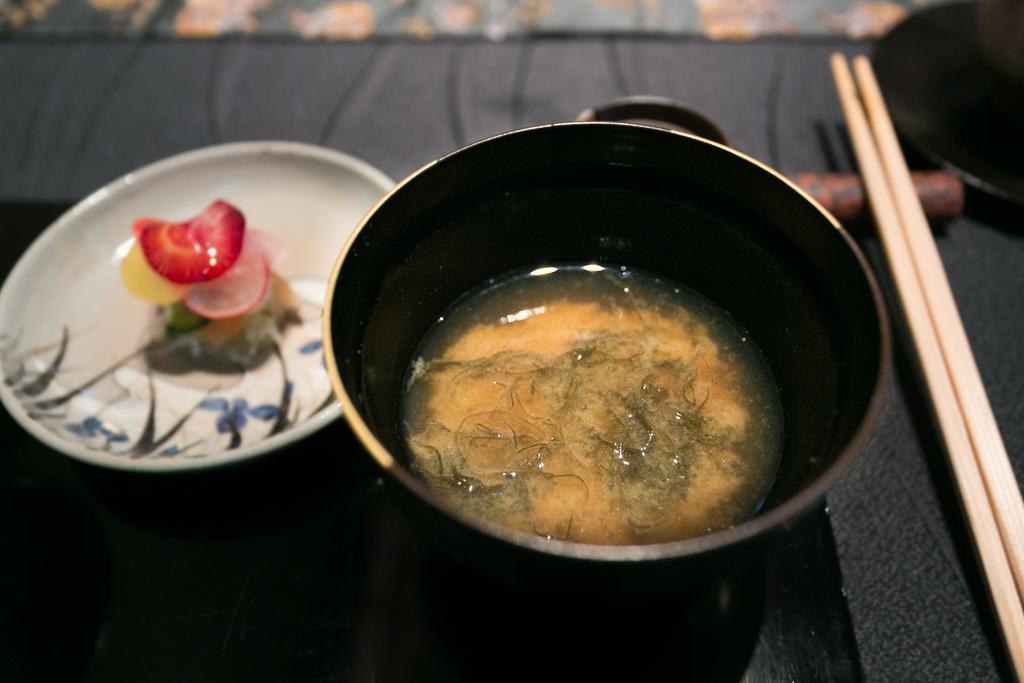In one or two sentences, can you explain what this image depicts? In the image we can see there is a bowl in which there is a soup and there are chopsticks kept on the tray. 